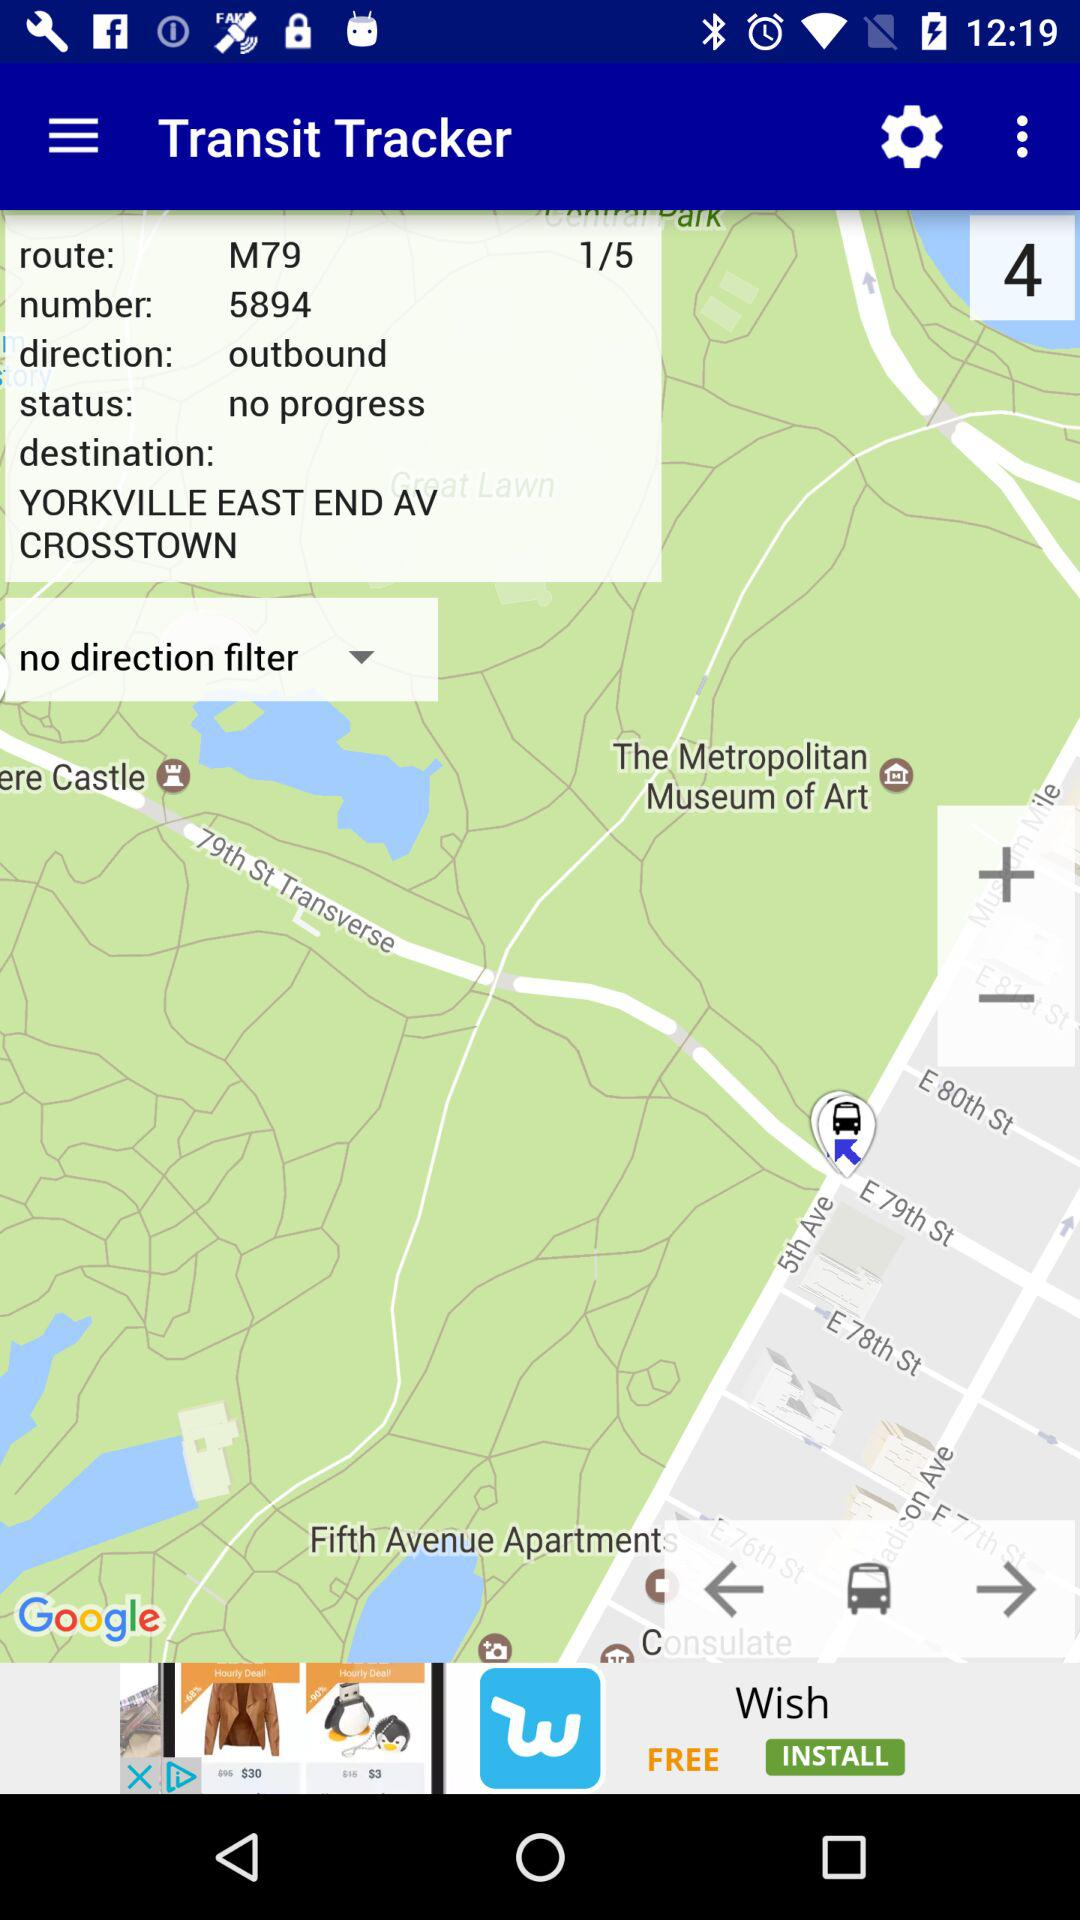In which state is The Metropolitan Museum of Art located?
When the provided information is insufficient, respond with <no answer>. <no answer> 